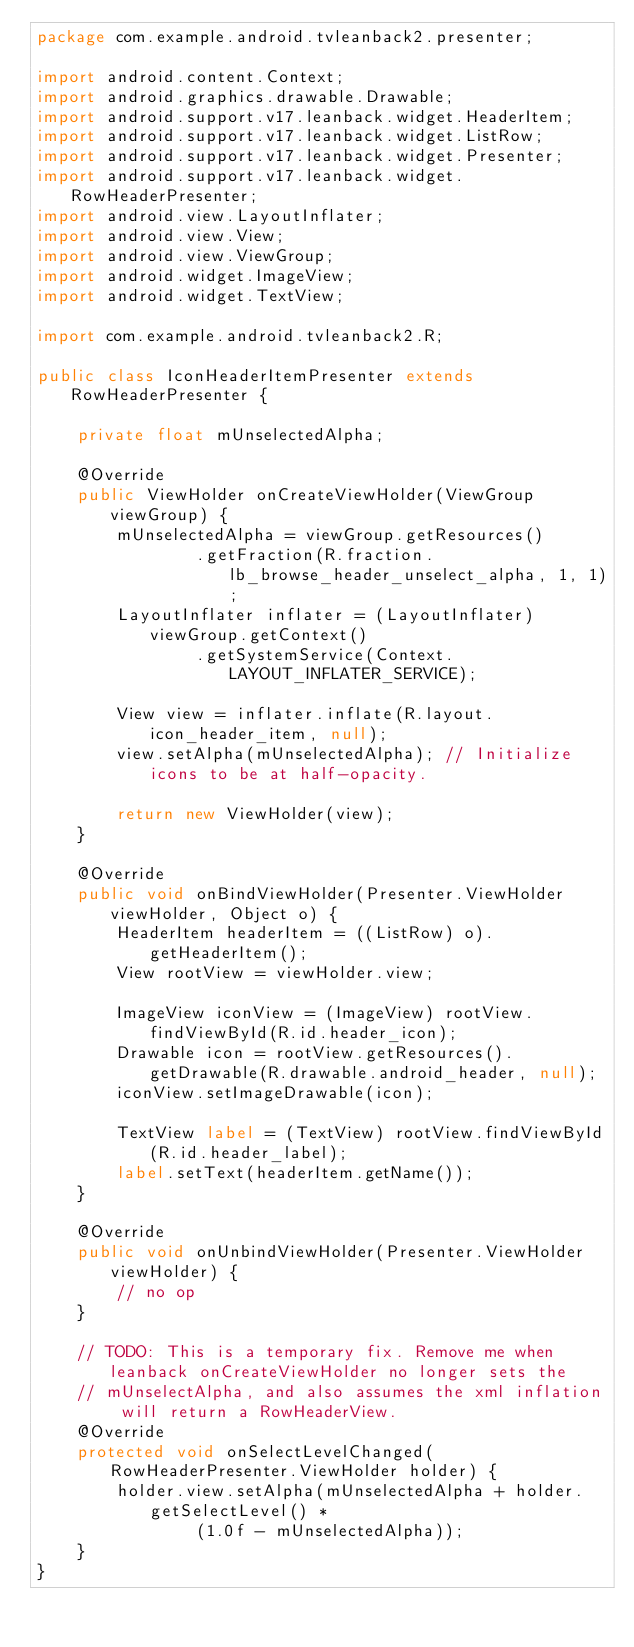Convert code to text. <code><loc_0><loc_0><loc_500><loc_500><_Java_>package com.example.android.tvleanback2.presenter;

import android.content.Context;
import android.graphics.drawable.Drawable;
import android.support.v17.leanback.widget.HeaderItem;
import android.support.v17.leanback.widget.ListRow;
import android.support.v17.leanback.widget.Presenter;
import android.support.v17.leanback.widget.RowHeaderPresenter;
import android.view.LayoutInflater;
import android.view.View;
import android.view.ViewGroup;
import android.widget.ImageView;
import android.widget.TextView;

import com.example.android.tvleanback2.R;

public class IconHeaderItemPresenter extends RowHeaderPresenter {

    private float mUnselectedAlpha;

    @Override
    public ViewHolder onCreateViewHolder(ViewGroup viewGroup) {
        mUnselectedAlpha = viewGroup.getResources()
                .getFraction(R.fraction.lb_browse_header_unselect_alpha, 1, 1);
        LayoutInflater inflater = (LayoutInflater) viewGroup.getContext()
                .getSystemService(Context.LAYOUT_INFLATER_SERVICE);

        View view = inflater.inflate(R.layout.icon_header_item, null);
        view.setAlpha(mUnselectedAlpha); // Initialize icons to be at half-opacity.

        return new ViewHolder(view);
    }

    @Override
    public void onBindViewHolder(Presenter.ViewHolder viewHolder, Object o) {
        HeaderItem headerItem = ((ListRow) o).getHeaderItem();
        View rootView = viewHolder.view;

        ImageView iconView = (ImageView) rootView.findViewById(R.id.header_icon);
        Drawable icon = rootView.getResources().getDrawable(R.drawable.android_header, null);
        iconView.setImageDrawable(icon);

        TextView label = (TextView) rootView.findViewById(R.id.header_label);
        label.setText(headerItem.getName());
    }

    @Override
    public void onUnbindViewHolder(Presenter.ViewHolder viewHolder) {
        // no op
    }

    // TODO: This is a temporary fix. Remove me when leanback onCreateViewHolder no longer sets the
    // mUnselectAlpha, and also assumes the xml inflation will return a RowHeaderView.
    @Override
    protected void onSelectLevelChanged(RowHeaderPresenter.ViewHolder holder) {
        holder.view.setAlpha(mUnselectedAlpha + holder.getSelectLevel() *
                (1.0f - mUnselectedAlpha));
    }
}
</code> 